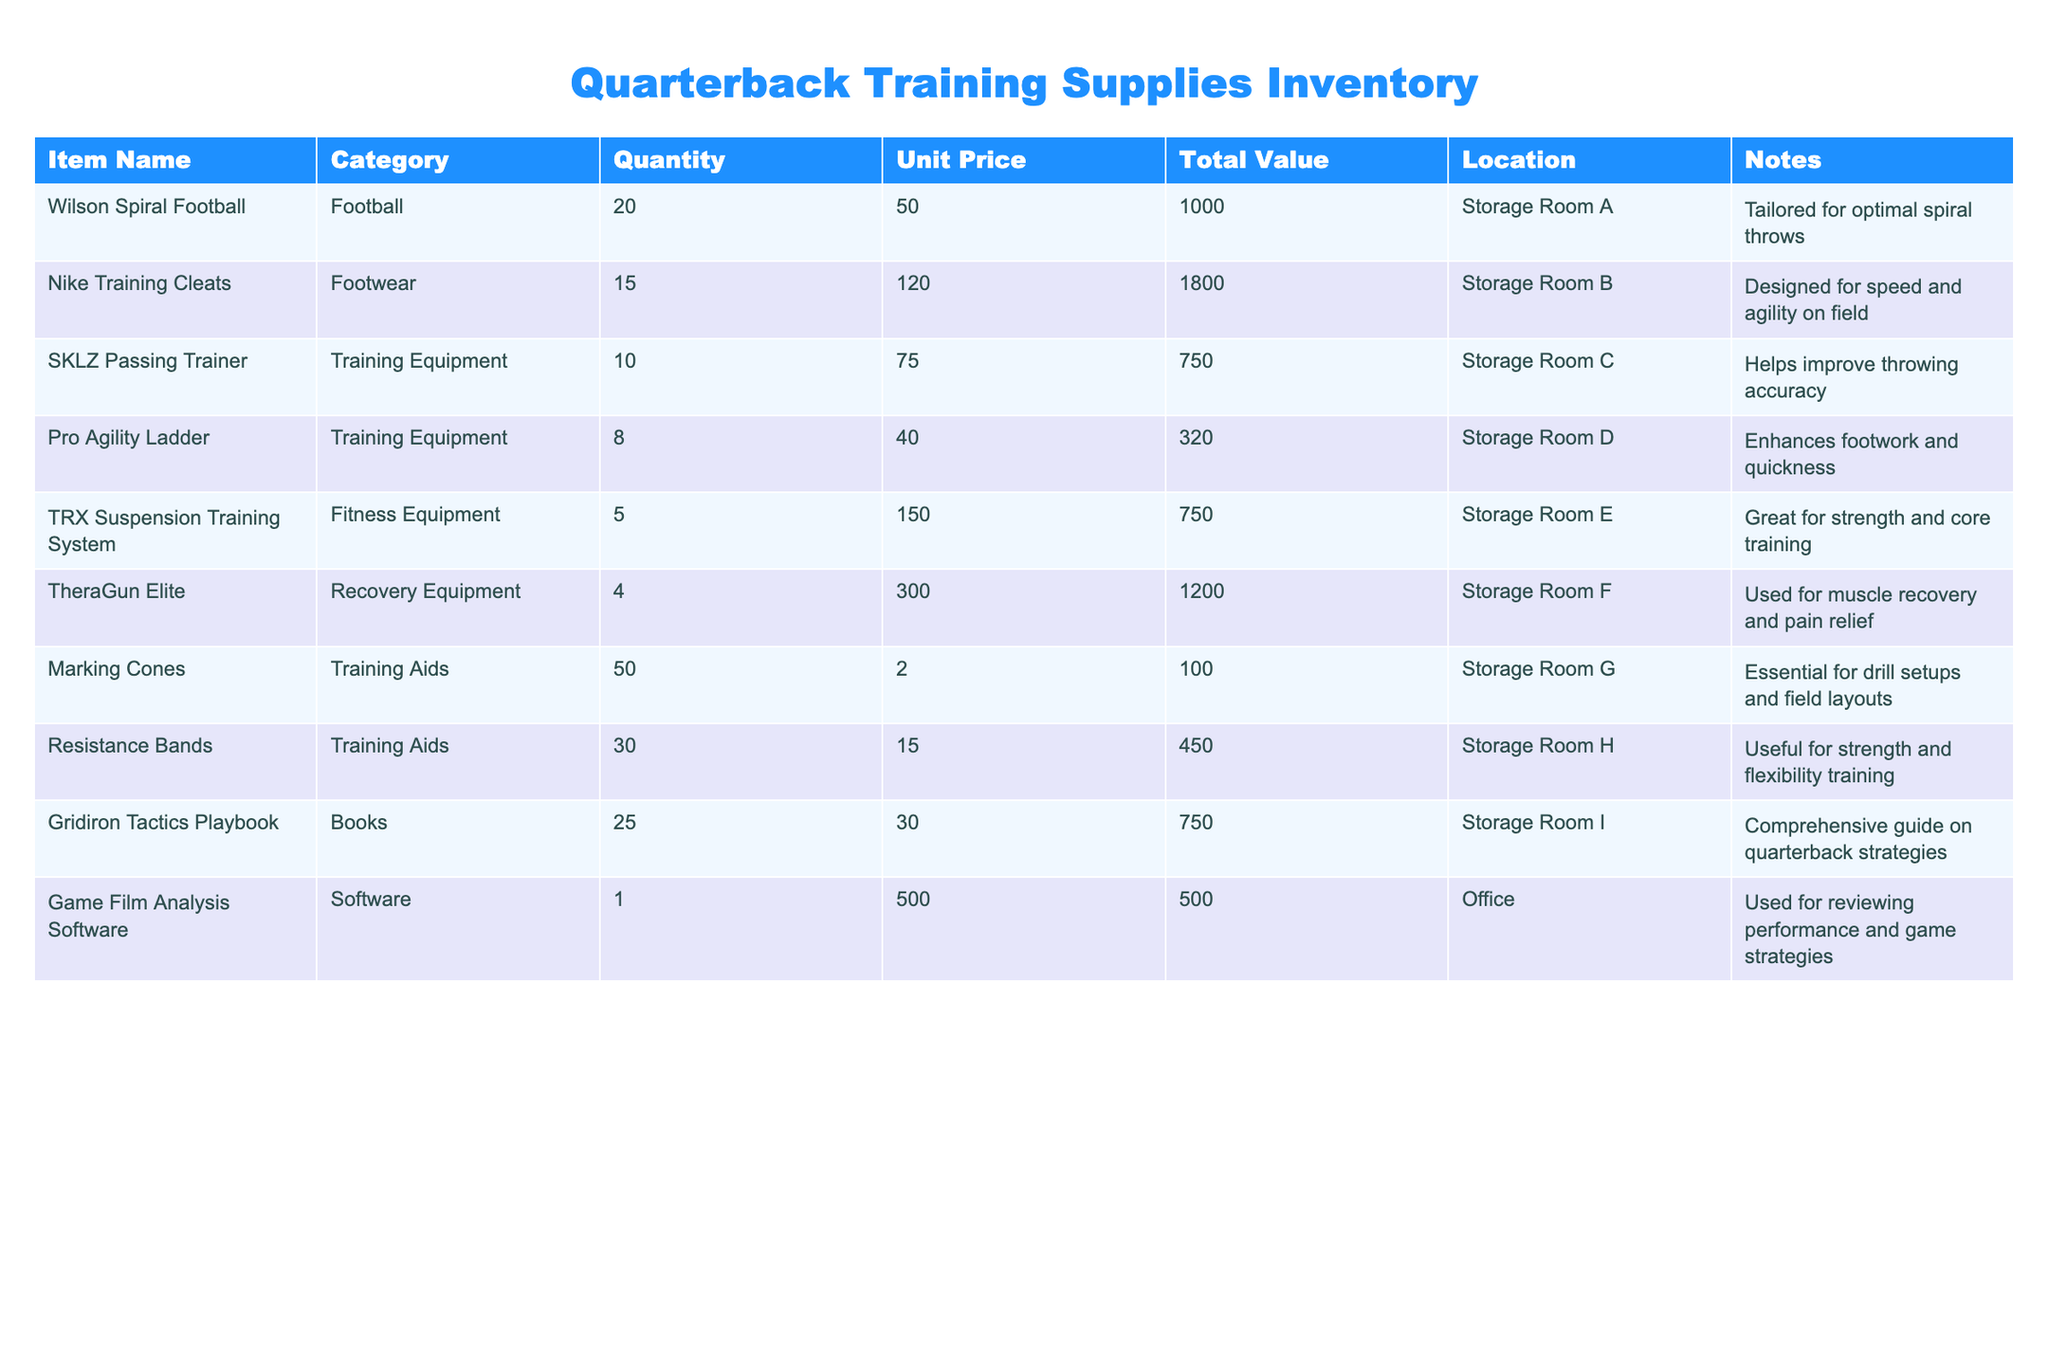What is the total number of footballs in inventory? There are 20 Wilson Spiral Footballs listed in the inventory under the "Quantity" column.
Answer: 20 How much does the TRX Suspension Training System cost? The unit price for the TRX Suspension Training System is listed as 150.00.
Answer: 150.00 What is the total value of the Recovery Equipment? The total value of the TheraGun Elite is 1200.00, and it is the only item in the Recovery Equipment category, so the total value remains 1200.00.
Answer: 1200.00 Which training aid has the highest quantity? The Marking Cones have 50 units, which is more than any other training aid listed, which includes Resistance Bands with 30 units.
Answer: Marking Cones What is the combined total value of all Training Equipment? The total values for Training Equipment items are SKLZ Passing Trainer (750.00) + Pro Agility Ladder (320.00), summing up: 750.00 + 320.00 = 1070.00.
Answer: 1070.00 Is there a specific item designed for speed and agility? Yes, the Nike Training Cleats are specifically designed for speed and agility on the field, as mentioned in the notes.
Answer: Yes What is the average unit price of all items in the inventory? To calculate the average unit price, sum the unit prices (50.00 + 120.00 + 75.00 + 40.00 + 150.00 + 300.00 + 2.00 + 15.00 + 30.00 + 500.00) = 1262.00. There are 10 items, so the average is 1262.00 / 10 = 126.20.
Answer: 126.20 Are there any items related to video analysis for quarterback performance? Yes, the Game Film Analysis Software is listed explicitly for reviewing performance and game strategies.
Answer: Yes What is the total quantity of footwear items available? The only footwear item listed is the Nike Training Cleats, which has a quantity of 15. Thus, the total quantity of footwear is 15.
Answer: 15 